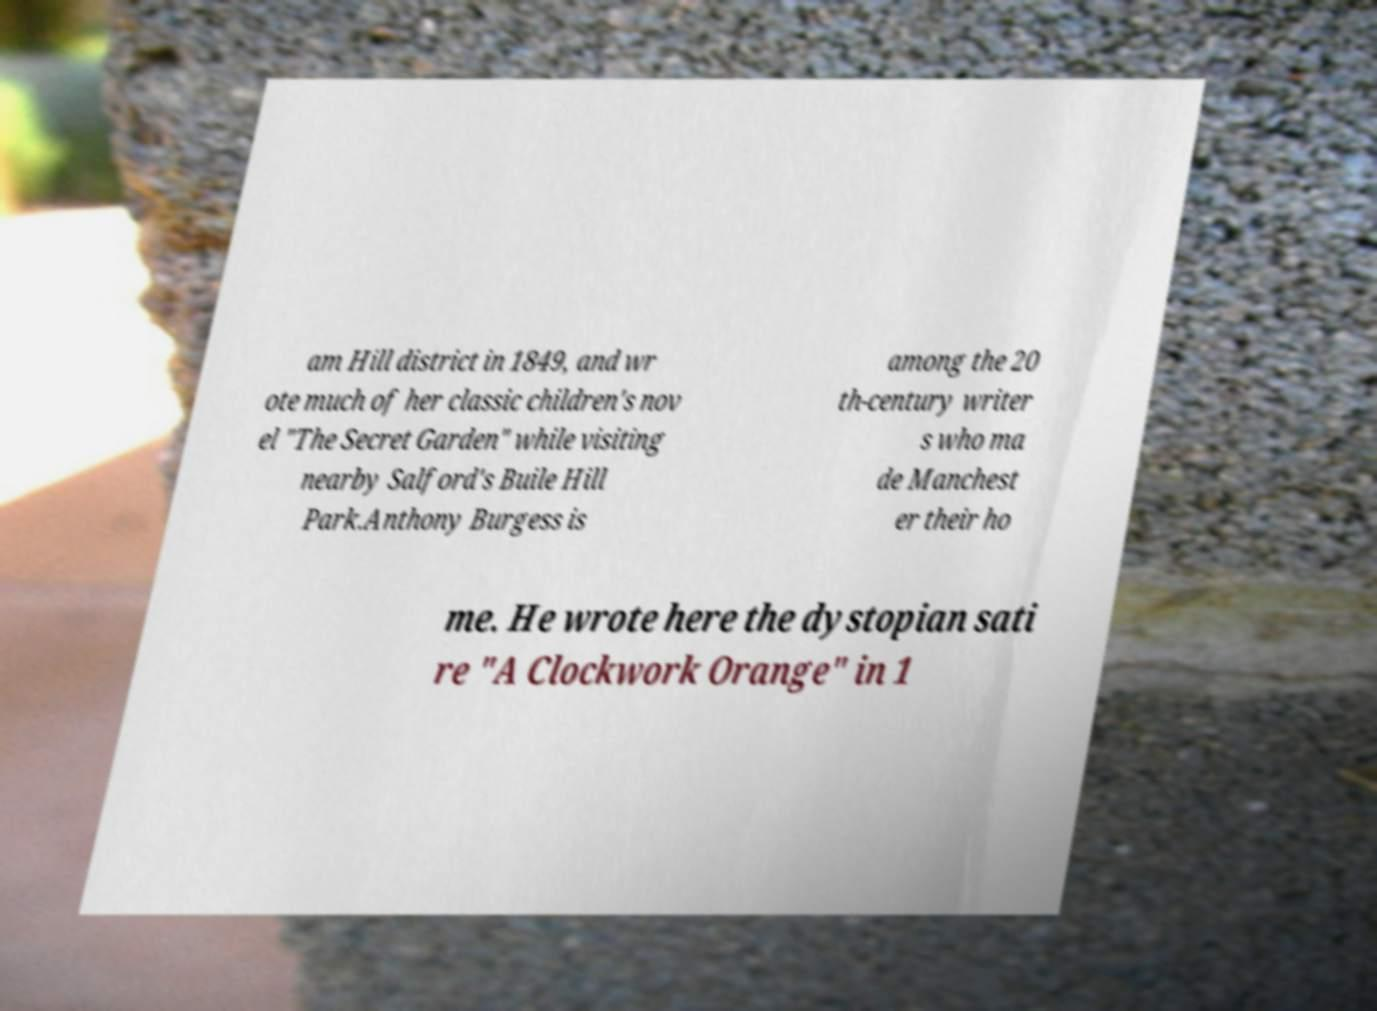Could you extract and type out the text from this image? am Hill district in 1849, and wr ote much of her classic children's nov el "The Secret Garden" while visiting nearby Salford's Buile Hill Park.Anthony Burgess is among the 20 th-century writer s who ma de Manchest er their ho me. He wrote here the dystopian sati re "A Clockwork Orange" in 1 